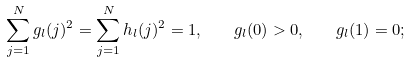Convert formula to latex. <formula><loc_0><loc_0><loc_500><loc_500>\sum _ { j = 1 } ^ { N } g _ { l } ( j ) ^ { 2 } = \sum _ { j = 1 } ^ { N } h _ { l } ( j ) ^ { 2 } = 1 , \quad g _ { l } ( 0 ) > 0 , \quad g _ { l } ( 1 ) = 0 ;</formula> 